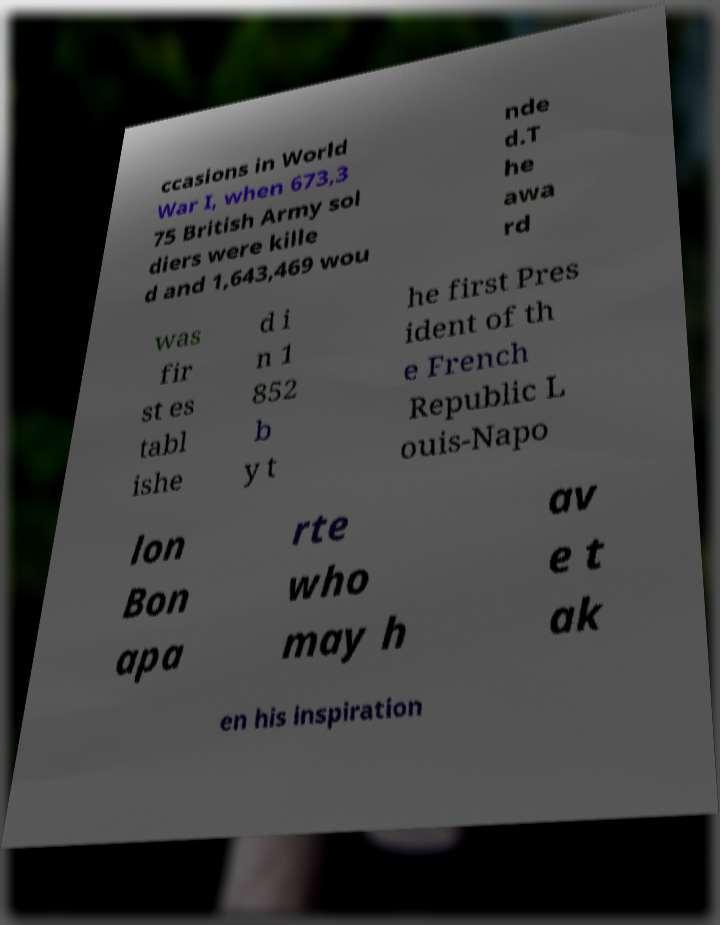Please identify and transcribe the text found in this image. ccasions in World War I, when 673,3 75 British Army sol diers were kille d and 1,643,469 wou nde d.T he awa rd was fir st es tabl ishe d i n 1 852 b y t he first Pres ident of th e French Republic L ouis-Napo lon Bon apa rte who may h av e t ak en his inspiration 